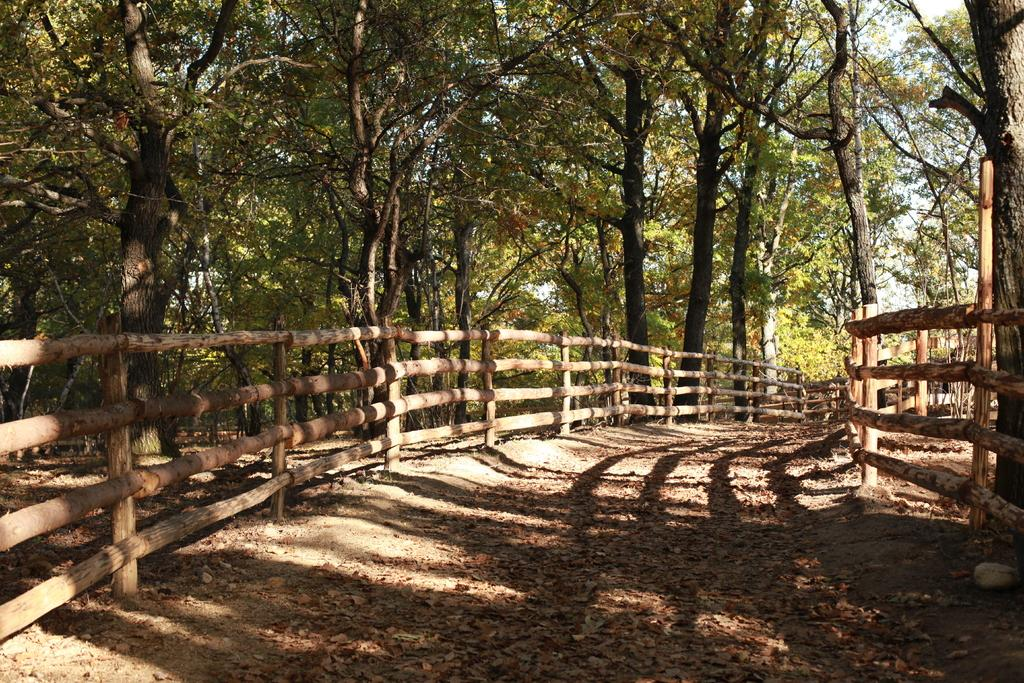What is on the ground in the image? There are dry leaves on the ground in the image. What type of fencing is present in the image? There is wooden fencing in the image. What can be seen in the background of the image? There are many trees in the background of the image. Can you see a donkey grazing near the wooden fencing in the image? No, there is no donkey present in the image. Are there any goldfish swimming in the trees in the background of the image? No, there are no goldfish present in the image. 